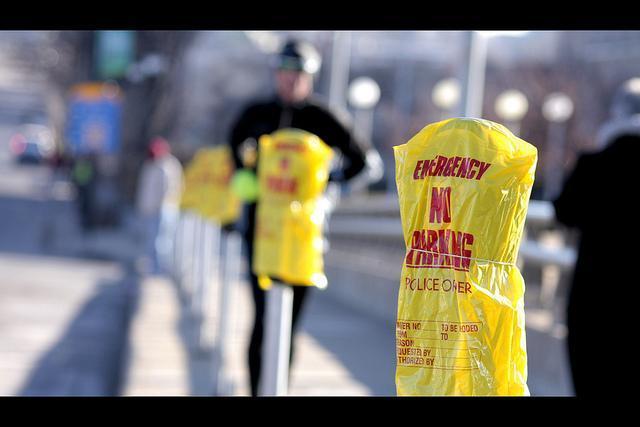How many people are in the picture?
Give a very brief answer. 3. How many parking meters are visible?
Give a very brief answer. 2. How many bananas are shown?
Give a very brief answer. 0. 